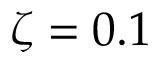Convert formula to latex. <formula><loc_0><loc_0><loc_500><loc_500>\zeta = 0 . 1</formula> 